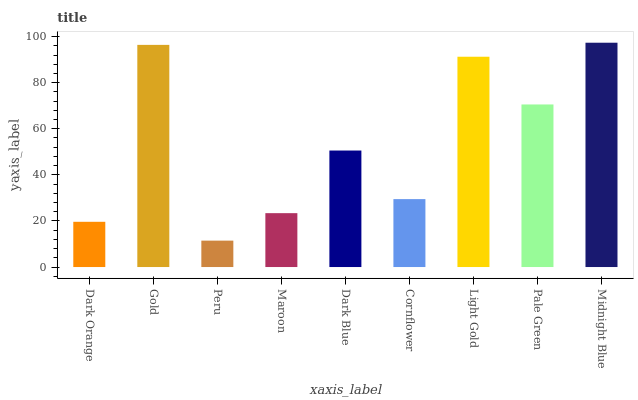Is Peru the minimum?
Answer yes or no. Yes. Is Midnight Blue the maximum?
Answer yes or no. Yes. Is Gold the minimum?
Answer yes or no. No. Is Gold the maximum?
Answer yes or no. No. Is Gold greater than Dark Orange?
Answer yes or no. Yes. Is Dark Orange less than Gold?
Answer yes or no. Yes. Is Dark Orange greater than Gold?
Answer yes or no. No. Is Gold less than Dark Orange?
Answer yes or no. No. Is Dark Blue the high median?
Answer yes or no. Yes. Is Dark Blue the low median?
Answer yes or no. Yes. Is Cornflower the high median?
Answer yes or no. No. Is Pale Green the low median?
Answer yes or no. No. 